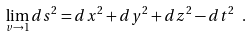<formula> <loc_0><loc_0><loc_500><loc_500>\lim _ { v \rightarrow 1 } d s ^ { 2 } = d x ^ { 2 } + d y ^ { 2 } + d z ^ { 2 } - d t ^ { 2 } \ .</formula> 